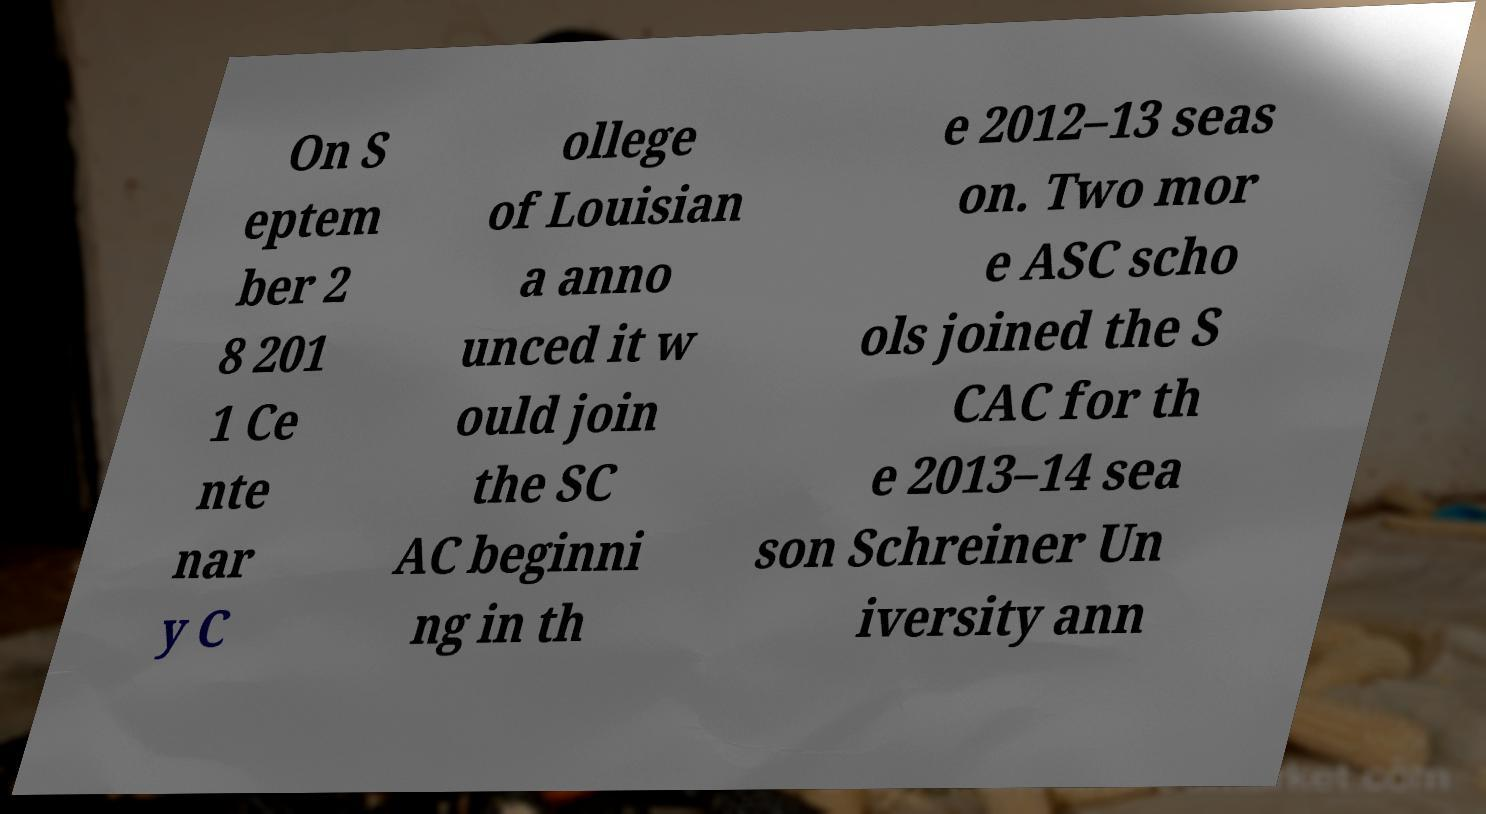Can you read and provide the text displayed in the image?This photo seems to have some interesting text. Can you extract and type it out for me? On S eptem ber 2 8 201 1 Ce nte nar y C ollege of Louisian a anno unced it w ould join the SC AC beginni ng in th e 2012–13 seas on. Two mor e ASC scho ols joined the S CAC for th e 2013–14 sea son Schreiner Un iversity ann 